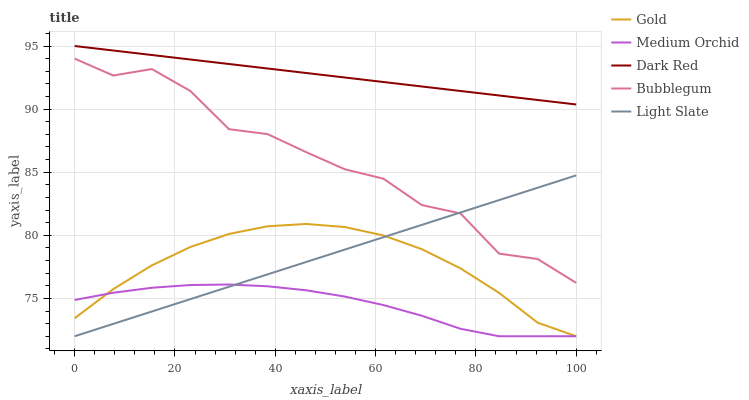Does Dark Red have the minimum area under the curve?
Answer yes or no. No. Does Medium Orchid have the maximum area under the curve?
Answer yes or no. No. Is Medium Orchid the smoothest?
Answer yes or no. No. Is Medium Orchid the roughest?
Answer yes or no. No. Does Dark Red have the lowest value?
Answer yes or no. No. Does Medium Orchid have the highest value?
Answer yes or no. No. Is Gold less than Bubblegum?
Answer yes or no. Yes. Is Dark Red greater than Light Slate?
Answer yes or no. Yes. Does Gold intersect Bubblegum?
Answer yes or no. No. 